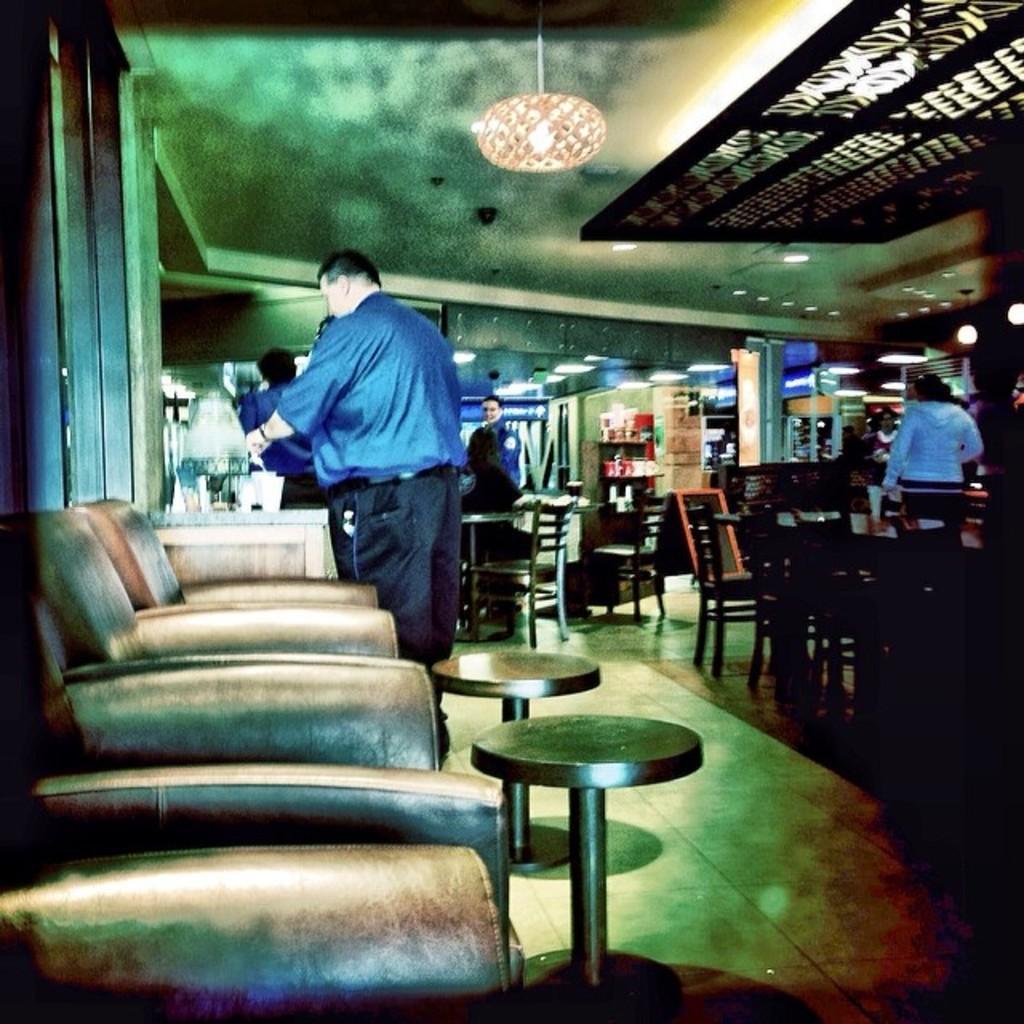Could you give a brief overview of what you see in this image? It seems to be the image is inside the restaurant, on left side of the image we can see few couches. In middle there is a man wearing a blue shirt standing and holding something and we can also see a table on left side. On right side there are few other tables in background there are group of people standing and some people are sitting on chairs and there is a door which is closed on top there is a roof. 